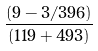<formula> <loc_0><loc_0><loc_500><loc_500>\frac { ( 9 - 3 / 3 9 6 ) } { ( 1 1 9 + 4 9 3 ) }</formula> 